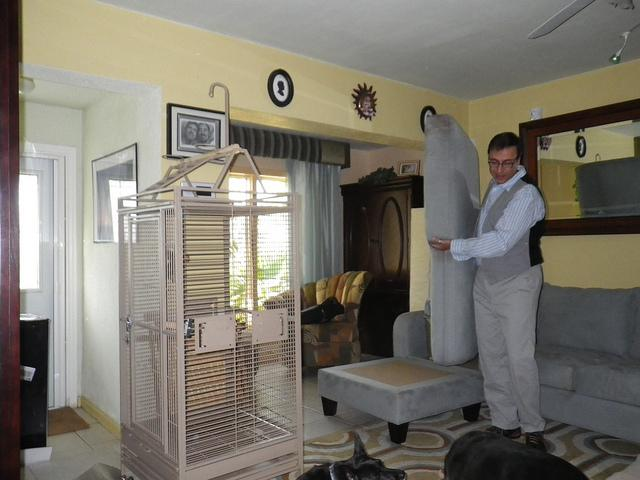Pet care Helpline number? 952 